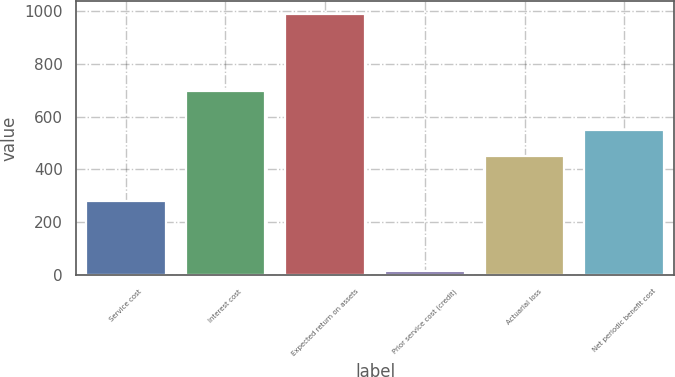Convert chart. <chart><loc_0><loc_0><loc_500><loc_500><bar_chart><fcel>Service cost<fcel>Interest cost<fcel>Expected return on assets<fcel>Prior service cost (credit)<fcel>Actuarial loss<fcel>Net periodic benefit cost<nl><fcel>280<fcel>698<fcel>988<fcel>15<fcel>450<fcel>547.3<nl></chart> 